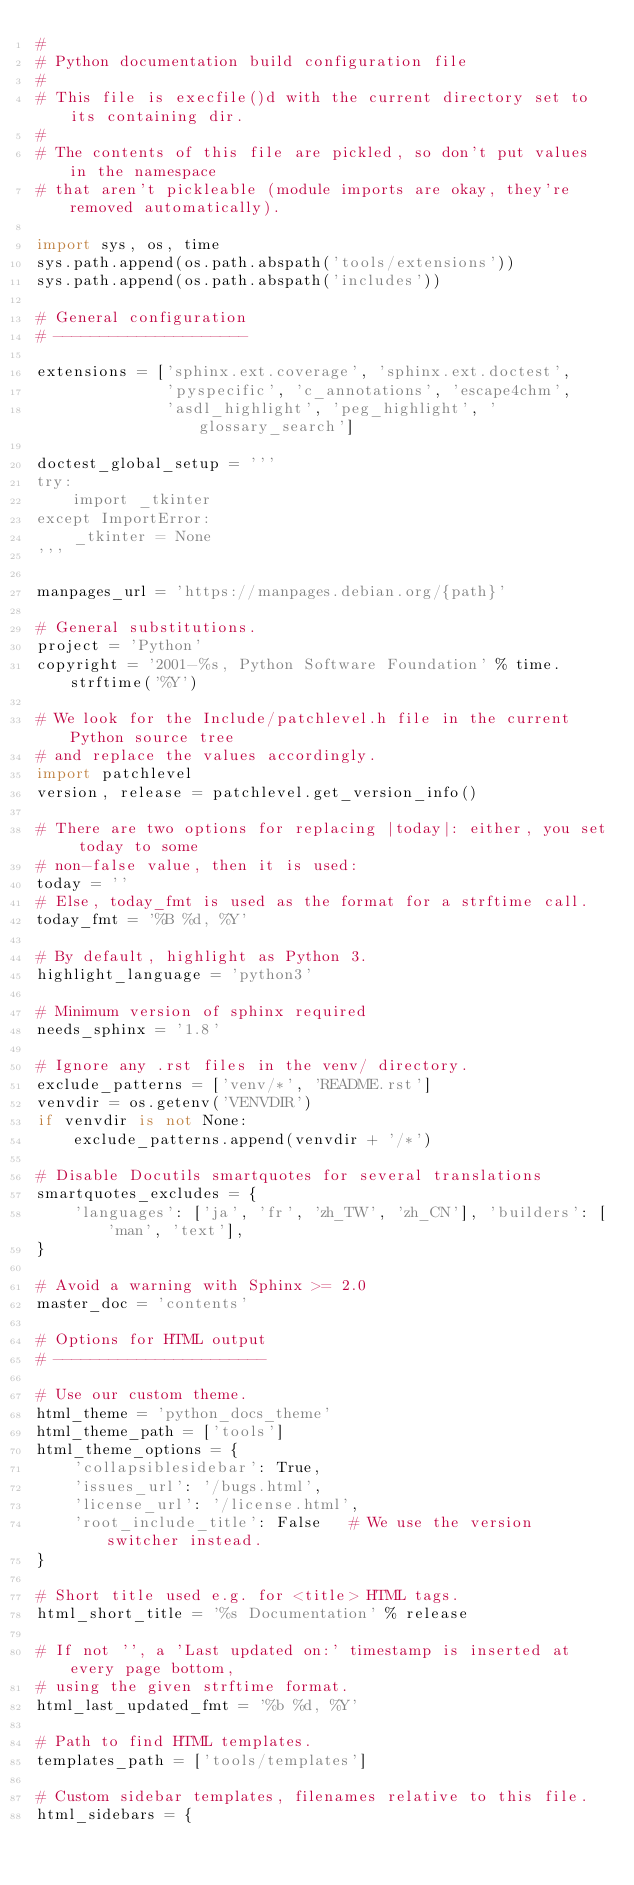Convert code to text. <code><loc_0><loc_0><loc_500><loc_500><_Python_>#
# Python documentation build configuration file
#
# This file is execfile()d with the current directory set to its containing dir.
#
# The contents of this file are pickled, so don't put values in the namespace
# that aren't pickleable (module imports are okay, they're removed automatically).

import sys, os, time
sys.path.append(os.path.abspath('tools/extensions'))
sys.path.append(os.path.abspath('includes'))

# General configuration
# ---------------------

extensions = ['sphinx.ext.coverage', 'sphinx.ext.doctest',
              'pyspecific', 'c_annotations', 'escape4chm',
              'asdl_highlight', 'peg_highlight', 'glossary_search']

doctest_global_setup = '''
try:
    import _tkinter
except ImportError:
    _tkinter = None
'''

manpages_url = 'https://manpages.debian.org/{path}'

# General substitutions.
project = 'Python'
copyright = '2001-%s, Python Software Foundation' % time.strftime('%Y')

# We look for the Include/patchlevel.h file in the current Python source tree
# and replace the values accordingly.
import patchlevel
version, release = patchlevel.get_version_info()

# There are two options for replacing |today|: either, you set today to some
# non-false value, then it is used:
today = ''
# Else, today_fmt is used as the format for a strftime call.
today_fmt = '%B %d, %Y'

# By default, highlight as Python 3.
highlight_language = 'python3'

# Minimum version of sphinx required
needs_sphinx = '1.8'

# Ignore any .rst files in the venv/ directory.
exclude_patterns = ['venv/*', 'README.rst']
venvdir = os.getenv('VENVDIR')
if venvdir is not None:
    exclude_patterns.append(venvdir + '/*')

# Disable Docutils smartquotes for several translations
smartquotes_excludes = {
    'languages': ['ja', 'fr', 'zh_TW', 'zh_CN'], 'builders': ['man', 'text'],
}

# Avoid a warning with Sphinx >= 2.0
master_doc = 'contents'

# Options for HTML output
# -----------------------

# Use our custom theme.
html_theme = 'python_docs_theme'
html_theme_path = ['tools']
html_theme_options = {
    'collapsiblesidebar': True,
    'issues_url': '/bugs.html',
    'license_url': '/license.html',
    'root_include_title': False   # We use the version switcher instead.
}

# Short title used e.g. for <title> HTML tags.
html_short_title = '%s Documentation' % release

# If not '', a 'Last updated on:' timestamp is inserted at every page bottom,
# using the given strftime format.
html_last_updated_fmt = '%b %d, %Y'

# Path to find HTML templates.
templates_path = ['tools/templates']

# Custom sidebar templates, filenames relative to this file.
html_sidebars = {</code> 